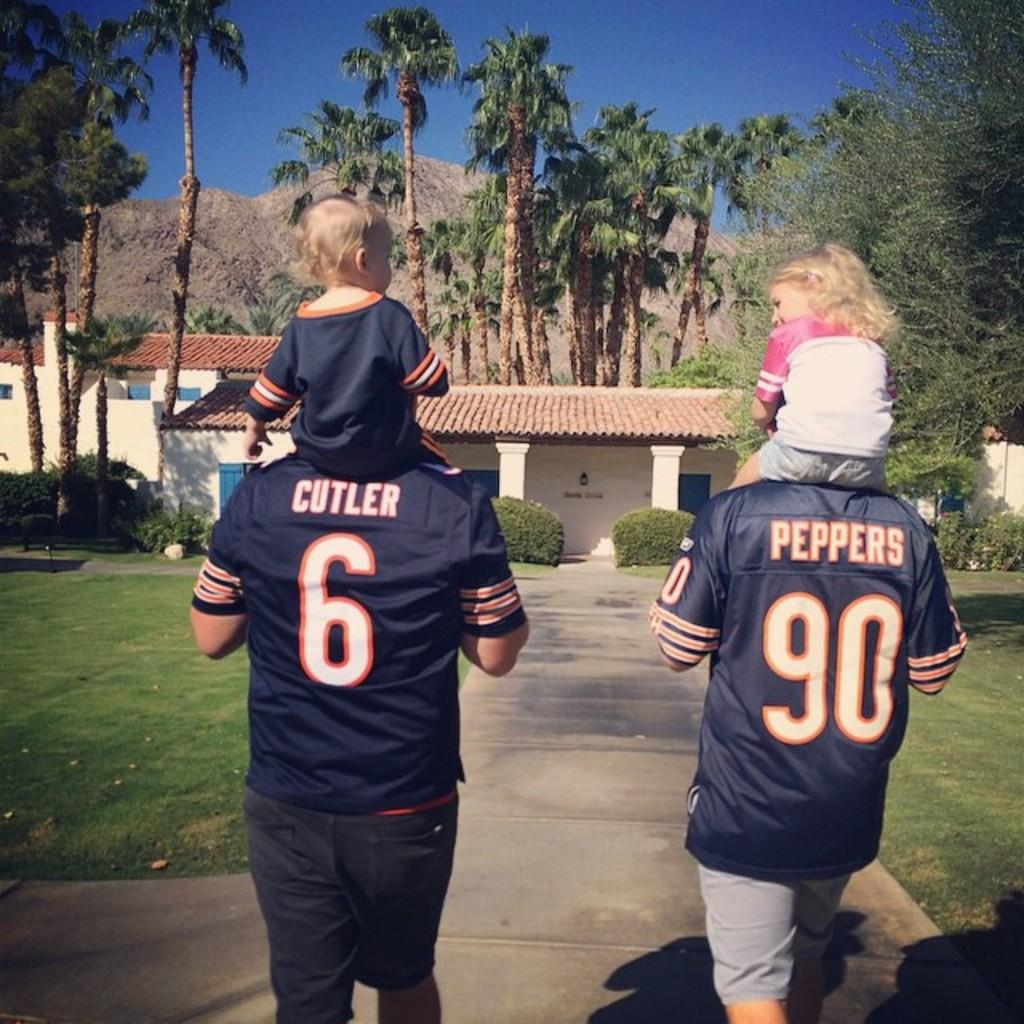<image>
Present a compact description of the photo's key features. Men in Cutler and Peppers uniforms carry children on their back as they walk down a sidewalk. 